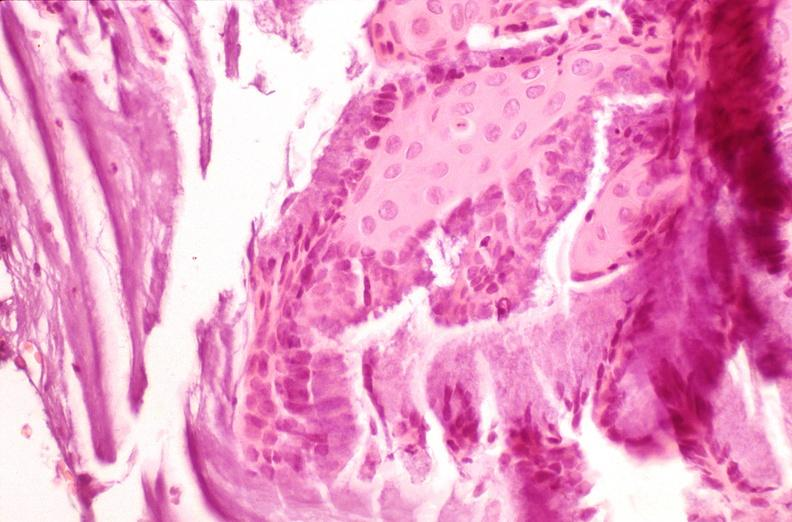what is present?
Answer the question using a single word or phrase. Female reproductive 